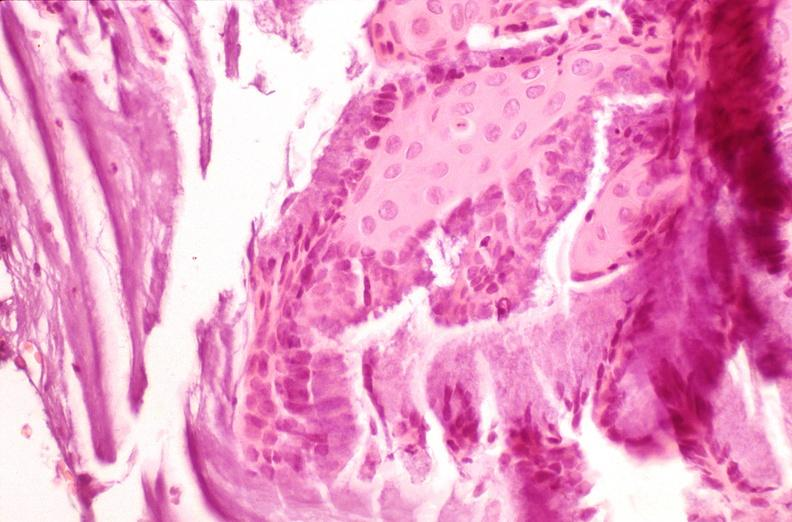what is present?
Answer the question using a single word or phrase. Female reproductive 